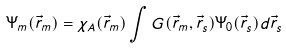<formula> <loc_0><loc_0><loc_500><loc_500>\Psi _ { m } ( \vec { r } _ { m } ) = \chi _ { A } ( \vec { r } _ { m } ) \int G ( \vec { r } _ { m } , \vec { r } _ { s } ) \Psi _ { 0 } ( \vec { r } _ { s } ) d \vec { r } _ { s }</formula> 